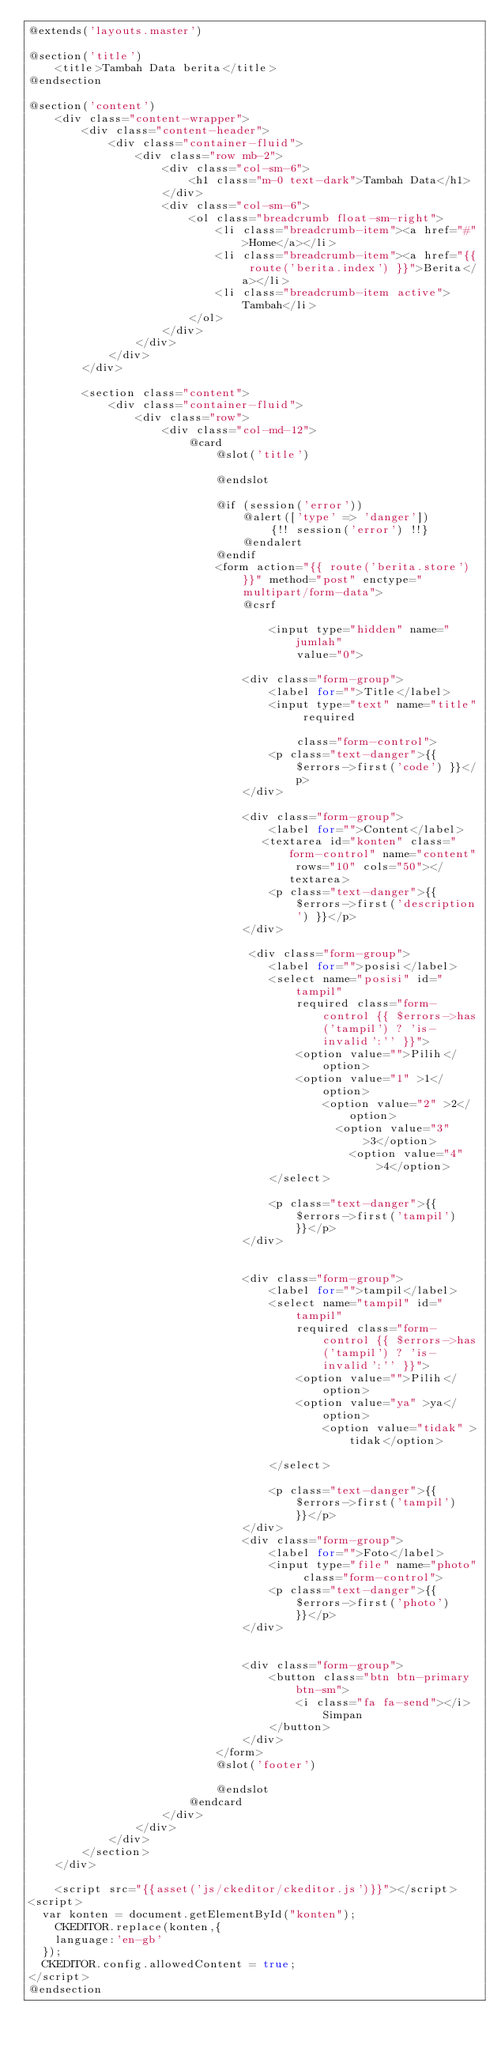Convert code to text. <code><loc_0><loc_0><loc_500><loc_500><_PHP_>@extends('layouts.master')

@section('title')
    <title>Tambah Data berita</title>
@endsection

@section('content')
    <div class="content-wrapper">
        <div class="content-header">
            <div class="container-fluid">
                <div class="row mb-2">
                    <div class="col-sm-6">
                        <h1 class="m-0 text-dark">Tambah Data</h1>
                    </div>
                    <div class="col-sm-6">
                        <ol class="breadcrumb float-sm-right">
                            <li class="breadcrumb-item"><a href="#">Home</a></li>
                            <li class="breadcrumb-item"><a href="{{ route('berita.index') }}">Berita</a></li>
                            <li class="breadcrumb-item active">Tambah</li>
                        </ol>
                    </div>
                </div>
            </div>
        </div>

        <section class="content">
            <div class="container-fluid">
                <div class="row">
                    <div class="col-md-12">
                        @card
                            @slot('title')
                            
                            @endslot
                            
                            @if (session('error'))
                                @alert(['type' => 'danger'])
                                    {!! session('error') !!}
                                @endalert
                            @endif
                            <form action="{{ route('berita.store') }}" method="post" enctype="multipart/form-data">
                                @csrf
                                
                                    <input type="hidden" name="jumlah"
                                        value="0">
                              
                                <div class="form-group">
                                    <label for="">Title</label>
                                    <input type="text" name="title" required 
                                        
                                        class="form-control">
                                    <p class="text-danger">{{ $errors->first('code') }}</p>
                                </div>
                               
                                <div class="form-group">
                                    <label for="">Content</label>
                                   <textarea id="konten" class="form-control" name="content" rows="10" cols="50"></textarea>
                                    <p class="text-danger">{{ $errors->first('description') }}</p>
                                </div>

                                 <div class="form-group">
                                    <label for="">posisi</label>
                                    <select name="posisi" id="tampil" 
                                        required class="form-control {{ $errors->has('tampil') ? 'is-invalid':'' }}">
                                        <option value="">Pilih</option>
                                        <option value="1" >1</option>
                                            <option value="2" >2</option>
                                              <option value="3" >3</option>
                                                <option value="4"  >4</option>
                                    </select>
                                    
                                    <p class="text-danger">{{ $errors->first('tampil') }}</p>
                                </div>


                                <div class="form-group">
                                    <label for="">tampil</label>
                                    <select name="tampil" id="tampil" 
                                        required class="form-control {{ $errors->has('tampil') ? 'is-invalid':'' }}">
                                        <option value="">Pilih</option>
                                        <option value="ya" >ya</option>
                                            <option value="tidak" >tidak</option>
                                      
                                    </select>
                                    
                                    <p class="text-danger">{{ $errors->first('tampil') }}</p>
                                </div>
                                <div class="form-group">
                                    <label for="">Foto</label>
                                    <input type="file" name="photo" class="form-control">
                                    <p class="text-danger">{{ $errors->first('photo') }}</p>
                                </div>
                                
                                
                                <div class="form-group">
                                    <button class="btn btn-primary btn-sm">
                                        <i class="fa fa-send"></i> Simpan
                                    </button>
                                </div>
                            </form>
                            @slot('footer')

                            @endslot
                        @endcard
                    </div>
                </div>
            </div>
        </section>
    </div>

    <script src="{{asset('js/ckeditor/ckeditor.js')}}"></script>
<script>
  var konten = document.getElementById("konten");
    CKEDITOR.replace(konten,{
    language:'en-gb'
  });
  CKEDITOR.config.allowedContent = true;
</script>
@endsection</code> 